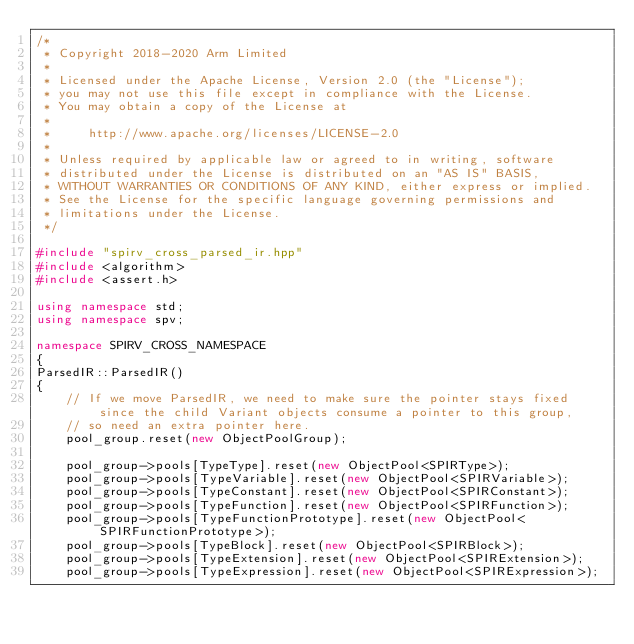Convert code to text. <code><loc_0><loc_0><loc_500><loc_500><_C++_>/*
 * Copyright 2018-2020 Arm Limited
 *
 * Licensed under the Apache License, Version 2.0 (the "License");
 * you may not use this file except in compliance with the License.
 * You may obtain a copy of the License at
 *
 *     http://www.apache.org/licenses/LICENSE-2.0
 *
 * Unless required by applicable law or agreed to in writing, software
 * distributed under the License is distributed on an "AS IS" BASIS,
 * WITHOUT WARRANTIES OR CONDITIONS OF ANY KIND, either express or implied.
 * See the License for the specific language governing permissions and
 * limitations under the License.
 */

#include "spirv_cross_parsed_ir.hpp"
#include <algorithm>
#include <assert.h>

using namespace std;
using namespace spv;

namespace SPIRV_CROSS_NAMESPACE
{
ParsedIR::ParsedIR()
{
	// If we move ParsedIR, we need to make sure the pointer stays fixed since the child Variant objects consume a pointer to this group,
	// so need an extra pointer here.
	pool_group.reset(new ObjectPoolGroup);

	pool_group->pools[TypeType].reset(new ObjectPool<SPIRType>);
	pool_group->pools[TypeVariable].reset(new ObjectPool<SPIRVariable>);
	pool_group->pools[TypeConstant].reset(new ObjectPool<SPIRConstant>);
	pool_group->pools[TypeFunction].reset(new ObjectPool<SPIRFunction>);
	pool_group->pools[TypeFunctionPrototype].reset(new ObjectPool<SPIRFunctionPrototype>);
	pool_group->pools[TypeBlock].reset(new ObjectPool<SPIRBlock>);
	pool_group->pools[TypeExtension].reset(new ObjectPool<SPIRExtension>);
	pool_group->pools[TypeExpression].reset(new ObjectPool<SPIRExpression>);</code> 